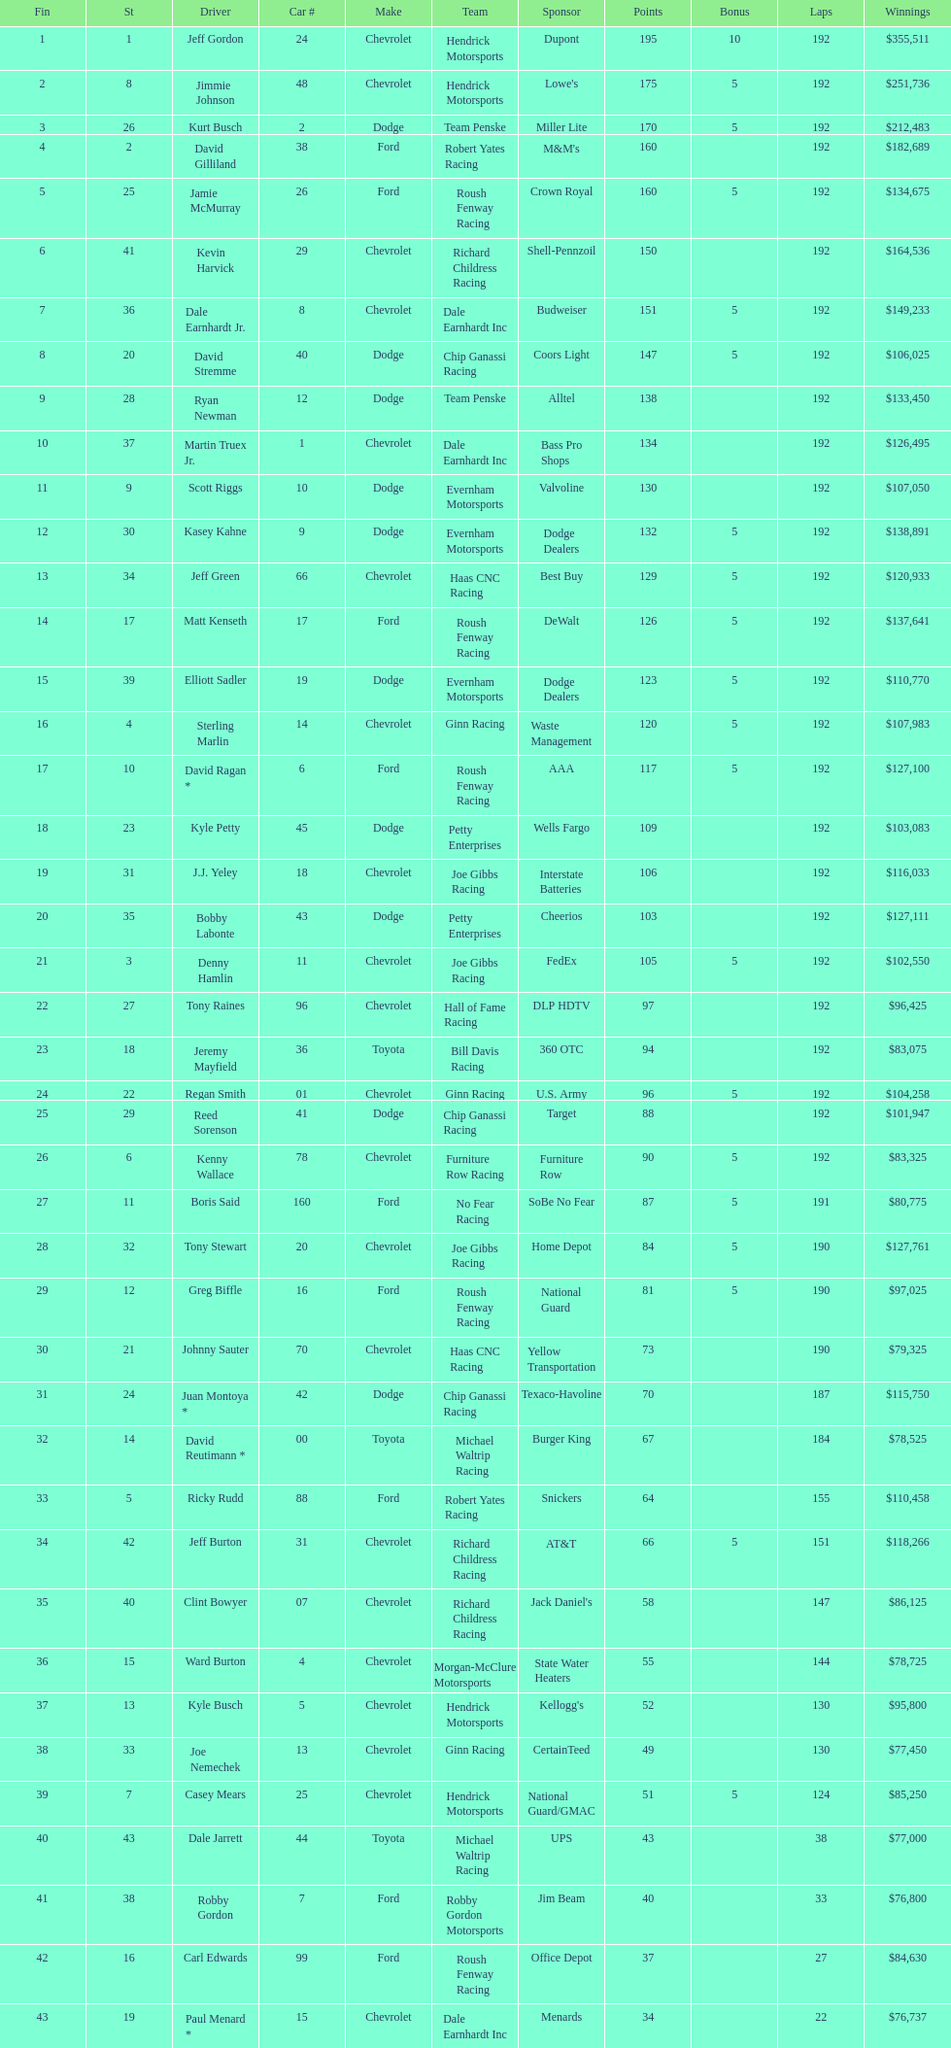How many race car drivers out of the 43 listed drove toyotas? 3. Can you give me this table as a dict? {'header': ['Fin', 'St', 'Driver', 'Car #', 'Make', 'Team', 'Sponsor', 'Points', 'Bonus', 'Laps', 'Winnings'], 'rows': [['1', '1', 'Jeff Gordon', '24', 'Chevrolet', 'Hendrick Motorsports', 'Dupont', '195', '10', '192', '$355,511'], ['2', '8', 'Jimmie Johnson', '48', 'Chevrolet', 'Hendrick Motorsports', "Lowe's", '175', '5', '192', '$251,736'], ['3', '26', 'Kurt Busch', '2', 'Dodge', 'Team Penske', 'Miller Lite', '170', '5', '192', '$212,483'], ['4', '2', 'David Gilliland', '38', 'Ford', 'Robert Yates Racing', "M&M's", '160', '', '192', '$182,689'], ['5', '25', 'Jamie McMurray', '26', 'Ford', 'Roush Fenway Racing', 'Crown Royal', '160', '5', '192', '$134,675'], ['6', '41', 'Kevin Harvick', '29', 'Chevrolet', 'Richard Childress Racing', 'Shell-Pennzoil', '150', '', '192', '$164,536'], ['7', '36', 'Dale Earnhardt Jr.', '8', 'Chevrolet', 'Dale Earnhardt Inc', 'Budweiser', '151', '5', '192', '$149,233'], ['8', '20', 'David Stremme', '40', 'Dodge', 'Chip Ganassi Racing', 'Coors Light', '147', '5', '192', '$106,025'], ['9', '28', 'Ryan Newman', '12', 'Dodge', 'Team Penske', 'Alltel', '138', '', '192', '$133,450'], ['10', '37', 'Martin Truex Jr.', '1', 'Chevrolet', 'Dale Earnhardt Inc', 'Bass Pro Shops', '134', '', '192', '$126,495'], ['11', '9', 'Scott Riggs', '10', 'Dodge', 'Evernham Motorsports', 'Valvoline', '130', '', '192', '$107,050'], ['12', '30', 'Kasey Kahne', '9', 'Dodge', 'Evernham Motorsports', 'Dodge Dealers', '132', '5', '192', '$138,891'], ['13', '34', 'Jeff Green', '66', 'Chevrolet', 'Haas CNC Racing', 'Best Buy', '129', '5', '192', '$120,933'], ['14', '17', 'Matt Kenseth', '17', 'Ford', 'Roush Fenway Racing', 'DeWalt', '126', '5', '192', '$137,641'], ['15', '39', 'Elliott Sadler', '19', 'Dodge', 'Evernham Motorsports', 'Dodge Dealers', '123', '5', '192', '$110,770'], ['16', '4', 'Sterling Marlin', '14', 'Chevrolet', 'Ginn Racing', 'Waste Management', '120', '5', '192', '$107,983'], ['17', '10', 'David Ragan *', '6', 'Ford', 'Roush Fenway Racing', 'AAA', '117', '5', '192', '$127,100'], ['18', '23', 'Kyle Petty', '45', 'Dodge', 'Petty Enterprises', 'Wells Fargo', '109', '', '192', '$103,083'], ['19', '31', 'J.J. Yeley', '18', 'Chevrolet', 'Joe Gibbs Racing', 'Interstate Batteries', '106', '', '192', '$116,033'], ['20', '35', 'Bobby Labonte', '43', 'Dodge', 'Petty Enterprises', 'Cheerios', '103', '', '192', '$127,111'], ['21', '3', 'Denny Hamlin', '11', 'Chevrolet', 'Joe Gibbs Racing', 'FedEx', '105', '5', '192', '$102,550'], ['22', '27', 'Tony Raines', '96', 'Chevrolet', 'Hall of Fame Racing', 'DLP HDTV', '97', '', '192', '$96,425'], ['23', '18', 'Jeremy Mayfield', '36', 'Toyota', 'Bill Davis Racing', '360 OTC', '94', '', '192', '$83,075'], ['24', '22', 'Regan Smith', '01', 'Chevrolet', 'Ginn Racing', 'U.S. Army', '96', '5', '192', '$104,258'], ['25', '29', 'Reed Sorenson', '41', 'Dodge', 'Chip Ganassi Racing', 'Target', '88', '', '192', '$101,947'], ['26', '6', 'Kenny Wallace', '78', 'Chevrolet', 'Furniture Row Racing', 'Furniture Row', '90', '5', '192', '$83,325'], ['27', '11', 'Boris Said', '160', 'Ford', 'No Fear Racing', 'SoBe No Fear', '87', '5', '191', '$80,775'], ['28', '32', 'Tony Stewart', '20', 'Chevrolet', 'Joe Gibbs Racing', 'Home Depot', '84', '5', '190', '$127,761'], ['29', '12', 'Greg Biffle', '16', 'Ford', 'Roush Fenway Racing', 'National Guard', '81', '5', '190', '$97,025'], ['30', '21', 'Johnny Sauter', '70', 'Chevrolet', 'Haas CNC Racing', 'Yellow Transportation', '73', '', '190', '$79,325'], ['31', '24', 'Juan Montoya *', '42', 'Dodge', 'Chip Ganassi Racing', 'Texaco-Havoline', '70', '', '187', '$115,750'], ['32', '14', 'David Reutimann *', '00', 'Toyota', 'Michael Waltrip Racing', 'Burger King', '67', '', '184', '$78,525'], ['33', '5', 'Ricky Rudd', '88', 'Ford', 'Robert Yates Racing', 'Snickers', '64', '', '155', '$110,458'], ['34', '42', 'Jeff Burton', '31', 'Chevrolet', 'Richard Childress Racing', 'AT&T', '66', '5', '151', '$118,266'], ['35', '40', 'Clint Bowyer', '07', 'Chevrolet', 'Richard Childress Racing', "Jack Daniel's", '58', '', '147', '$86,125'], ['36', '15', 'Ward Burton', '4', 'Chevrolet', 'Morgan-McClure Motorsports', 'State Water Heaters', '55', '', '144', '$78,725'], ['37', '13', 'Kyle Busch', '5', 'Chevrolet', 'Hendrick Motorsports', "Kellogg's", '52', '', '130', '$95,800'], ['38', '33', 'Joe Nemechek', '13', 'Chevrolet', 'Ginn Racing', 'CertainTeed', '49', '', '130', '$77,450'], ['39', '7', 'Casey Mears', '25', 'Chevrolet', 'Hendrick Motorsports', 'National Guard/GMAC', '51', '5', '124', '$85,250'], ['40', '43', 'Dale Jarrett', '44', 'Toyota', 'Michael Waltrip Racing', 'UPS', '43', '', '38', '$77,000'], ['41', '38', 'Robby Gordon', '7', 'Ford', 'Robby Gordon Motorsports', 'Jim Beam', '40', '', '33', '$76,800'], ['42', '16', 'Carl Edwards', '99', 'Ford', 'Roush Fenway Racing', 'Office Depot', '37', '', '27', '$84,630'], ['43', '19', 'Paul Menard *', '15', 'Chevrolet', 'Dale Earnhardt Inc', 'Menards', '34', '', '22', '$76,737']]} 